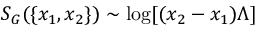Convert formula to latex. <formula><loc_0><loc_0><loc_500><loc_500>S _ { G } ( \{ x _ { 1 } , x _ { 2 } \} ) \sim \log [ ( x _ { 2 } - x _ { 1 } ) \Lambda ]</formula> 